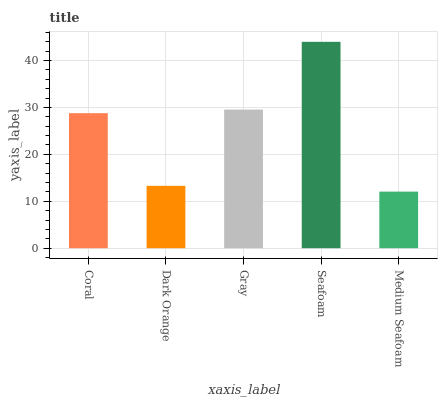Is Medium Seafoam the minimum?
Answer yes or no. Yes. Is Seafoam the maximum?
Answer yes or no. Yes. Is Dark Orange the minimum?
Answer yes or no. No. Is Dark Orange the maximum?
Answer yes or no. No. Is Coral greater than Dark Orange?
Answer yes or no. Yes. Is Dark Orange less than Coral?
Answer yes or no. Yes. Is Dark Orange greater than Coral?
Answer yes or no. No. Is Coral less than Dark Orange?
Answer yes or no. No. Is Coral the high median?
Answer yes or no. Yes. Is Coral the low median?
Answer yes or no. Yes. Is Medium Seafoam the high median?
Answer yes or no. No. Is Dark Orange the low median?
Answer yes or no. No. 